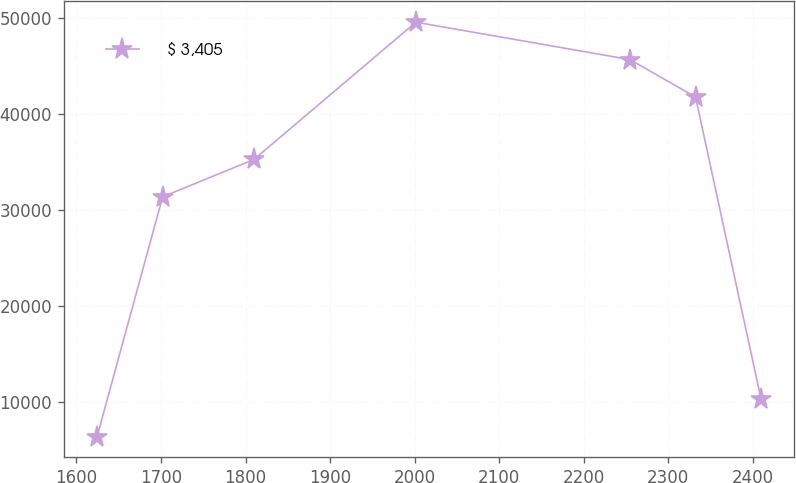Convert chart. <chart><loc_0><loc_0><loc_500><loc_500><line_chart><ecel><fcel>$ 3,405<nl><fcel>1624.36<fcel>6432.55<nl><fcel>1701.94<fcel>31405.1<nl><fcel>1810.04<fcel>35298.5<nl><fcel>2001.58<fcel>49584.6<nl><fcel>2254.86<fcel>45691.1<nl><fcel>2332.44<fcel>41797.7<nl><fcel>2410.02<fcel>10326<nl></chart> 